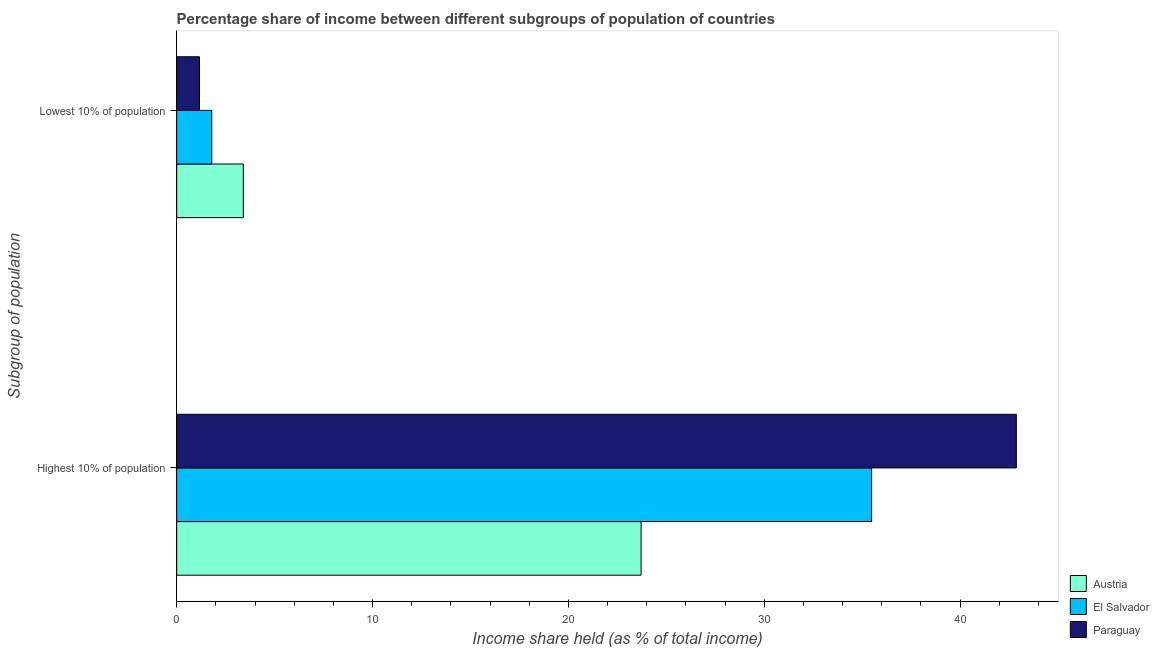How many groups of bars are there?
Provide a short and direct response. 2. How many bars are there on the 1st tick from the top?
Provide a succinct answer. 3. How many bars are there on the 2nd tick from the bottom?
Provide a short and direct response. 3. What is the label of the 1st group of bars from the top?
Offer a very short reply. Lowest 10% of population. What is the income share held by lowest 10% of the population in Austria?
Your answer should be compact. 3.4. Across all countries, what is the maximum income share held by highest 10% of the population?
Offer a terse response. 42.87. Across all countries, what is the minimum income share held by highest 10% of the population?
Make the answer very short. 23.71. In which country was the income share held by lowest 10% of the population maximum?
Provide a short and direct response. Austria. In which country was the income share held by lowest 10% of the population minimum?
Your response must be concise. Paraguay. What is the total income share held by highest 10% of the population in the graph?
Make the answer very short. 102.06. What is the difference between the income share held by lowest 10% of the population in El Salvador and that in Austria?
Offer a very short reply. -1.61. What is the difference between the income share held by lowest 10% of the population in El Salvador and the income share held by highest 10% of the population in Austria?
Make the answer very short. -21.92. What is the average income share held by highest 10% of the population per country?
Make the answer very short. 34.02. What is the difference between the income share held by highest 10% of the population and income share held by lowest 10% of the population in El Salvador?
Your answer should be very brief. 33.69. In how many countries, is the income share held by lowest 10% of the population greater than 14 %?
Your response must be concise. 0. What is the ratio of the income share held by lowest 10% of the population in Paraguay to that in Austria?
Your answer should be very brief. 0.34. Is the income share held by lowest 10% of the population in Paraguay less than that in Austria?
Provide a succinct answer. Yes. In how many countries, is the income share held by lowest 10% of the population greater than the average income share held by lowest 10% of the population taken over all countries?
Make the answer very short. 1. What does the 2nd bar from the top in Lowest 10% of population represents?
Offer a terse response. El Salvador. What does the 1st bar from the bottom in Highest 10% of population represents?
Your answer should be very brief. Austria. How many bars are there?
Provide a succinct answer. 6. Are the values on the major ticks of X-axis written in scientific E-notation?
Ensure brevity in your answer.  No. Does the graph contain any zero values?
Provide a short and direct response. No. Does the graph contain grids?
Keep it short and to the point. No. Where does the legend appear in the graph?
Ensure brevity in your answer.  Bottom right. How many legend labels are there?
Make the answer very short. 3. How are the legend labels stacked?
Make the answer very short. Vertical. What is the title of the graph?
Your response must be concise. Percentage share of income between different subgroups of population of countries. What is the label or title of the X-axis?
Make the answer very short. Income share held (as % of total income). What is the label or title of the Y-axis?
Make the answer very short. Subgroup of population. What is the Income share held (as % of total income) of Austria in Highest 10% of population?
Ensure brevity in your answer.  23.71. What is the Income share held (as % of total income) of El Salvador in Highest 10% of population?
Provide a succinct answer. 35.48. What is the Income share held (as % of total income) of Paraguay in Highest 10% of population?
Provide a short and direct response. 42.87. What is the Income share held (as % of total income) of Austria in Lowest 10% of population?
Ensure brevity in your answer.  3.4. What is the Income share held (as % of total income) of El Salvador in Lowest 10% of population?
Your answer should be compact. 1.79. What is the Income share held (as % of total income) in Paraguay in Lowest 10% of population?
Your answer should be compact. 1.16. Across all Subgroup of population, what is the maximum Income share held (as % of total income) in Austria?
Ensure brevity in your answer.  23.71. Across all Subgroup of population, what is the maximum Income share held (as % of total income) in El Salvador?
Your answer should be compact. 35.48. Across all Subgroup of population, what is the maximum Income share held (as % of total income) in Paraguay?
Provide a succinct answer. 42.87. Across all Subgroup of population, what is the minimum Income share held (as % of total income) in El Salvador?
Offer a terse response. 1.79. Across all Subgroup of population, what is the minimum Income share held (as % of total income) of Paraguay?
Provide a short and direct response. 1.16. What is the total Income share held (as % of total income) of Austria in the graph?
Give a very brief answer. 27.11. What is the total Income share held (as % of total income) of El Salvador in the graph?
Ensure brevity in your answer.  37.27. What is the total Income share held (as % of total income) in Paraguay in the graph?
Offer a very short reply. 44.03. What is the difference between the Income share held (as % of total income) of Austria in Highest 10% of population and that in Lowest 10% of population?
Your response must be concise. 20.31. What is the difference between the Income share held (as % of total income) in El Salvador in Highest 10% of population and that in Lowest 10% of population?
Give a very brief answer. 33.69. What is the difference between the Income share held (as % of total income) in Paraguay in Highest 10% of population and that in Lowest 10% of population?
Make the answer very short. 41.71. What is the difference between the Income share held (as % of total income) in Austria in Highest 10% of population and the Income share held (as % of total income) in El Salvador in Lowest 10% of population?
Provide a short and direct response. 21.92. What is the difference between the Income share held (as % of total income) of Austria in Highest 10% of population and the Income share held (as % of total income) of Paraguay in Lowest 10% of population?
Provide a short and direct response. 22.55. What is the difference between the Income share held (as % of total income) of El Salvador in Highest 10% of population and the Income share held (as % of total income) of Paraguay in Lowest 10% of population?
Your answer should be compact. 34.32. What is the average Income share held (as % of total income) in Austria per Subgroup of population?
Keep it short and to the point. 13.55. What is the average Income share held (as % of total income) in El Salvador per Subgroup of population?
Offer a very short reply. 18.64. What is the average Income share held (as % of total income) of Paraguay per Subgroup of population?
Provide a short and direct response. 22.02. What is the difference between the Income share held (as % of total income) in Austria and Income share held (as % of total income) in El Salvador in Highest 10% of population?
Offer a very short reply. -11.77. What is the difference between the Income share held (as % of total income) in Austria and Income share held (as % of total income) in Paraguay in Highest 10% of population?
Offer a very short reply. -19.16. What is the difference between the Income share held (as % of total income) in El Salvador and Income share held (as % of total income) in Paraguay in Highest 10% of population?
Your answer should be compact. -7.39. What is the difference between the Income share held (as % of total income) in Austria and Income share held (as % of total income) in El Salvador in Lowest 10% of population?
Provide a succinct answer. 1.61. What is the difference between the Income share held (as % of total income) of Austria and Income share held (as % of total income) of Paraguay in Lowest 10% of population?
Offer a terse response. 2.24. What is the difference between the Income share held (as % of total income) in El Salvador and Income share held (as % of total income) in Paraguay in Lowest 10% of population?
Make the answer very short. 0.63. What is the ratio of the Income share held (as % of total income) of Austria in Highest 10% of population to that in Lowest 10% of population?
Offer a terse response. 6.97. What is the ratio of the Income share held (as % of total income) in El Salvador in Highest 10% of population to that in Lowest 10% of population?
Make the answer very short. 19.82. What is the ratio of the Income share held (as % of total income) of Paraguay in Highest 10% of population to that in Lowest 10% of population?
Offer a very short reply. 36.96. What is the difference between the highest and the second highest Income share held (as % of total income) of Austria?
Ensure brevity in your answer.  20.31. What is the difference between the highest and the second highest Income share held (as % of total income) in El Salvador?
Ensure brevity in your answer.  33.69. What is the difference between the highest and the second highest Income share held (as % of total income) of Paraguay?
Offer a terse response. 41.71. What is the difference between the highest and the lowest Income share held (as % of total income) of Austria?
Offer a very short reply. 20.31. What is the difference between the highest and the lowest Income share held (as % of total income) in El Salvador?
Your response must be concise. 33.69. What is the difference between the highest and the lowest Income share held (as % of total income) of Paraguay?
Your answer should be very brief. 41.71. 